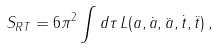<formula> <loc_0><loc_0><loc_500><loc_500>S _ { R T } = 6 \pi ^ { 2 } \int d \tau \, L ( a , \dot { a } , \ddot { a } , \dot { t } , \ddot { t } ) \, ,</formula> 